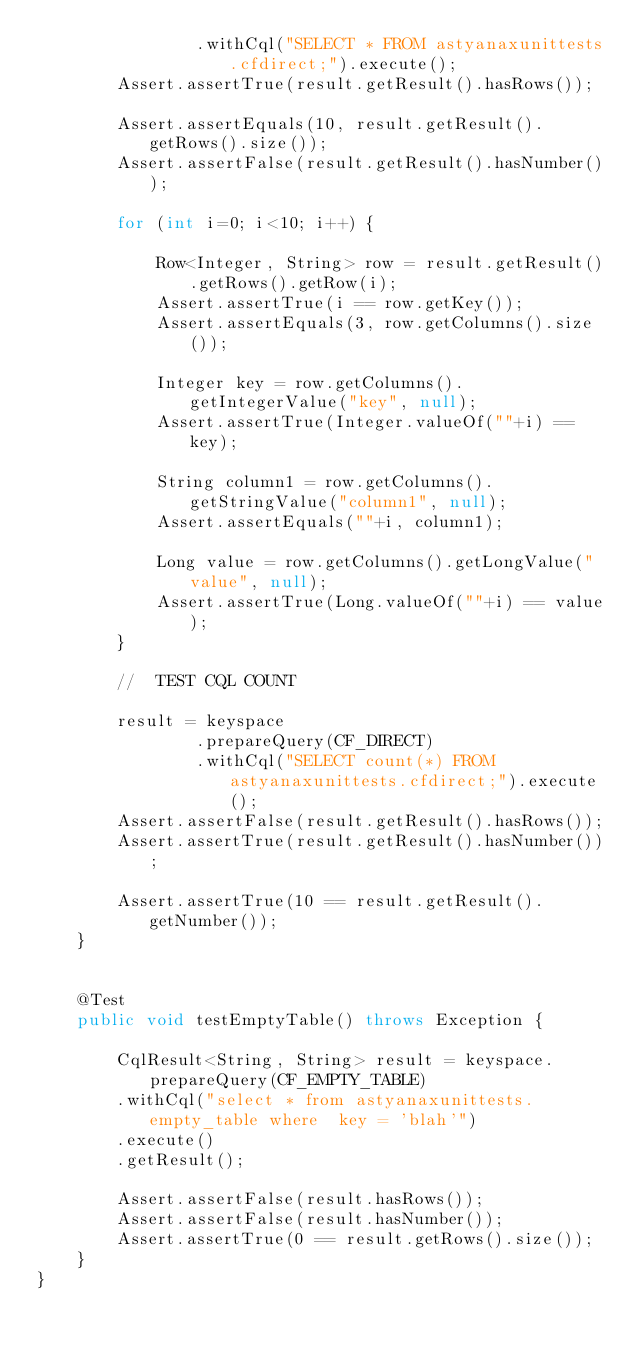Convert code to text. <code><loc_0><loc_0><loc_500><loc_500><_Java_>    			.withCql("SELECT * FROM astyanaxunittests.cfdirect;").execute();
    	Assert.assertTrue(result.getResult().hasRows());

    	Assert.assertEquals(10, result.getResult().getRows().size());
    	Assert.assertFalse(result.getResult().hasNumber());
    	
    	for (int i=0; i<10; i++) {
    		
    		Row<Integer, String> row = result.getResult().getRows().getRow(i);
        	Assert.assertTrue(i == row.getKey());
        	Assert.assertEquals(3, row.getColumns().size());
        	
        	Integer key = row.getColumns().getIntegerValue("key", null);
        	Assert.assertTrue(Integer.valueOf(""+i) == key);

        	String column1 = row.getColumns().getStringValue("column1", null);
        	Assert.assertEquals(""+i, column1);
        	
        	Long value = row.getColumns().getLongValue("value", null);
        	Assert.assertTrue(Long.valueOf(""+i) == value);
    	}
    	
    	//  TEST CQL COUNT

    	result = keyspace
    			.prepareQuery(CF_DIRECT)
    			.withCql("SELECT count(*) FROM astyanaxunittests.cfdirect;").execute();
    	Assert.assertFalse(result.getResult().hasRows());
    	Assert.assertTrue(result.getResult().hasNumber());

    	Assert.assertTrue(10 == result.getResult().getNumber());
    }
    
    
    @Test 
    public void testEmptyTable() throws Exception {

    	CqlResult<String, String> result = keyspace.prepareQuery(CF_EMPTY_TABLE)
    	.withCql("select * from astyanaxunittests.empty_table where  key = 'blah'")
    	.execute()
    	.getResult();
    	
    	Assert.assertFalse(result.hasRows());
    	Assert.assertFalse(result.hasNumber());
    	Assert.assertTrue(0 == result.getRows().size());
    }
}
</code> 